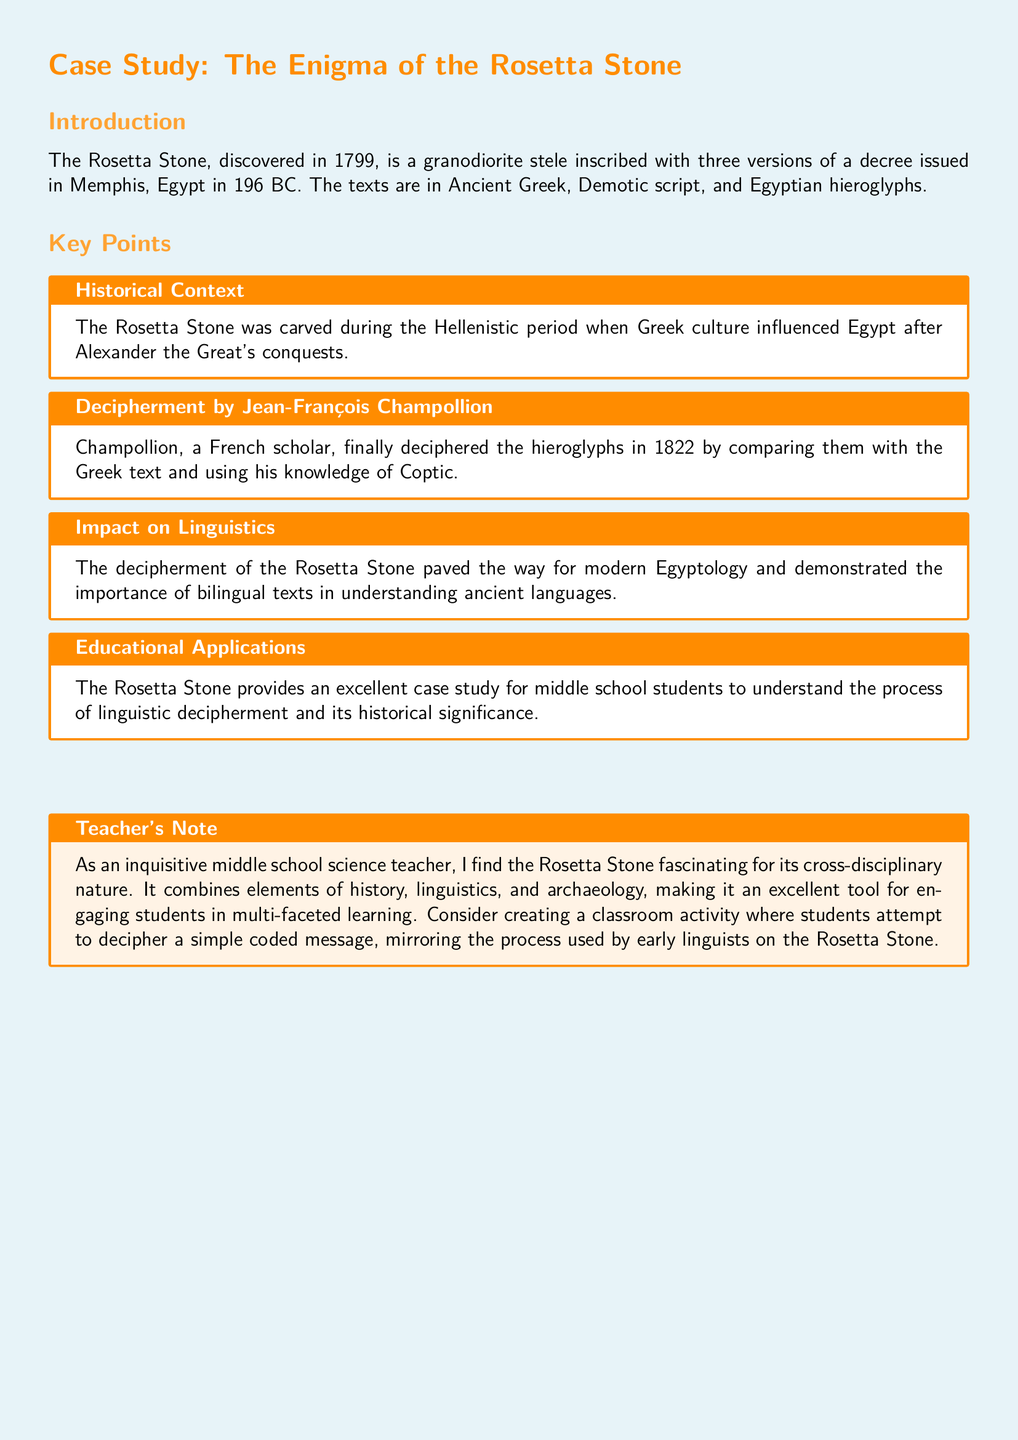What year was the Rosetta Stone discovered? The document states that the Rosetta Stone was discovered in the year 1799.
Answer: 1799 Who deciphered the hieroglyphs on the Rosetta Stone? According to the document, the hieroglyphs were deciphered by Jean-François Champollion.
Answer: Jean-François Champollion What three languages are inscribed on the Rosetta Stone? The document lists Ancient Greek, Demotic script, and Egyptian hieroglyphs as the three languages.
Answer: Ancient Greek, Demotic script, and Egyptian hieroglyphs What significant impact did the Rosetta Stone have on modern linguistics? The document mentions that its decipherment paved the way for modern Egyptology.
Answer: Modern Egyptology What is the historical context of the Rosetta Stone? The document states it was carved during the Hellenistic period, influenced by Greek culture.
Answer: Hellenistic period What classroom activity is suggested in the teacher's note? The teacher's note proposes a classroom activity where students attempt to decipher a simple coded message.
Answer: Decipher a simple coded message In what year did Champollion decipher the hieroglyphs? The document notes that Champollion deciphered the hieroglyphs in 1822.
Answer: 1822 What type of artifact is the Rosetta Stone classified as? Based on the document, the Rosetta Stone is classified as a granodiorite stele.
Answer: Granodiorite stele 